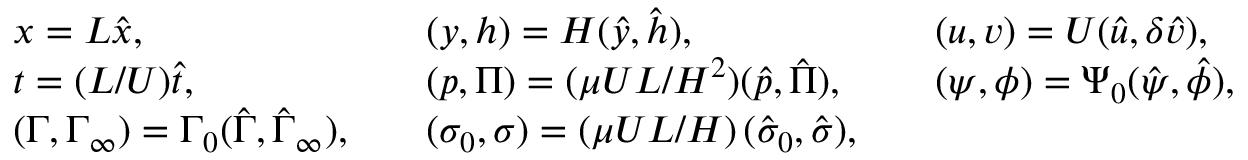<formula> <loc_0><loc_0><loc_500><loc_500>\begin{array} { l l l } { x = L \hat { x } , } & { \quad ( y , h ) = H ( \hat { y } , \hat { h } ) , } & { \quad ( u , v ) = U ( \hat { u } , \delta \hat { v } ) , } \\ { t = ( L / U ) \hat { t } , } & { \quad ( p , \Pi ) = ( \mu U L / H ^ { 2 } ) ( \hat { p } , \hat { \Pi } ) , } & { \quad ( \psi , \phi ) = \Psi _ { 0 } ( \hat { \psi } , \hat { \phi } ) , } \\ { ( \Gamma , \Gamma _ { \infty } ) = \Gamma _ { 0 } ( \hat { \Gamma } , \hat { \Gamma } _ { \infty } ) , } & { \quad ( \sigma _ { 0 } , \sigma ) = \left ( \mu U L / H \right ) ( \hat { \sigma } _ { 0 } , \hat { \sigma } ) , } & \end{array}</formula> 